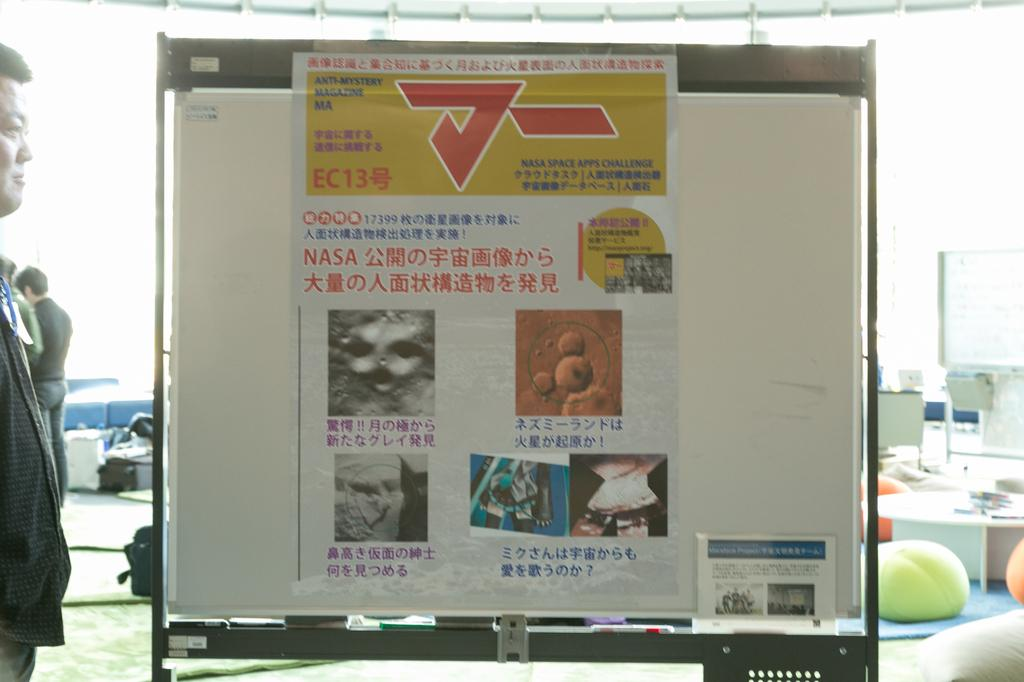<image>
Offer a succinct explanation of the picture presented. A yellow box with EC13 under a red symbol is displayed on a board. 